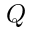<formula> <loc_0><loc_0><loc_500><loc_500>Q</formula> 